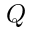<formula> <loc_0><loc_0><loc_500><loc_500>Q</formula> 